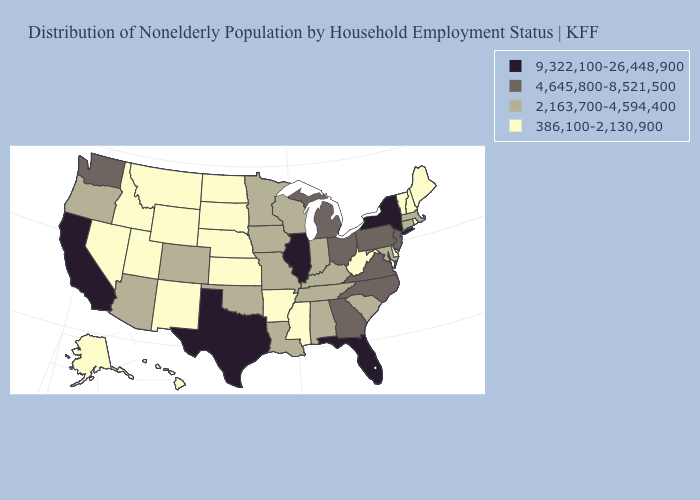Does Texas have the highest value in the USA?
Answer briefly. Yes. Which states hav the highest value in the West?
Quick response, please. California. Does North Dakota have the lowest value in the MidWest?
Quick response, please. Yes. Name the states that have a value in the range 9,322,100-26,448,900?
Concise answer only. California, Florida, Illinois, New York, Texas. Does the map have missing data?
Answer briefly. No. What is the value of Indiana?
Concise answer only. 2,163,700-4,594,400. Which states hav the highest value in the Northeast?
Be succinct. New York. What is the value of Virginia?
Be succinct. 4,645,800-8,521,500. Does Alabama have the highest value in the USA?
Concise answer only. No. What is the value of Arkansas?
Concise answer only. 386,100-2,130,900. Among the states that border Indiana , does Illinois have the lowest value?
Be succinct. No. What is the lowest value in the USA?
Answer briefly. 386,100-2,130,900. Among the states that border New Jersey , which have the highest value?
Be succinct. New York. Name the states that have a value in the range 9,322,100-26,448,900?
Short answer required. California, Florida, Illinois, New York, Texas. Which states have the lowest value in the USA?
Quick response, please. Alaska, Arkansas, Delaware, Hawaii, Idaho, Kansas, Maine, Mississippi, Montana, Nebraska, Nevada, New Hampshire, New Mexico, North Dakota, Rhode Island, South Dakota, Utah, Vermont, West Virginia, Wyoming. 